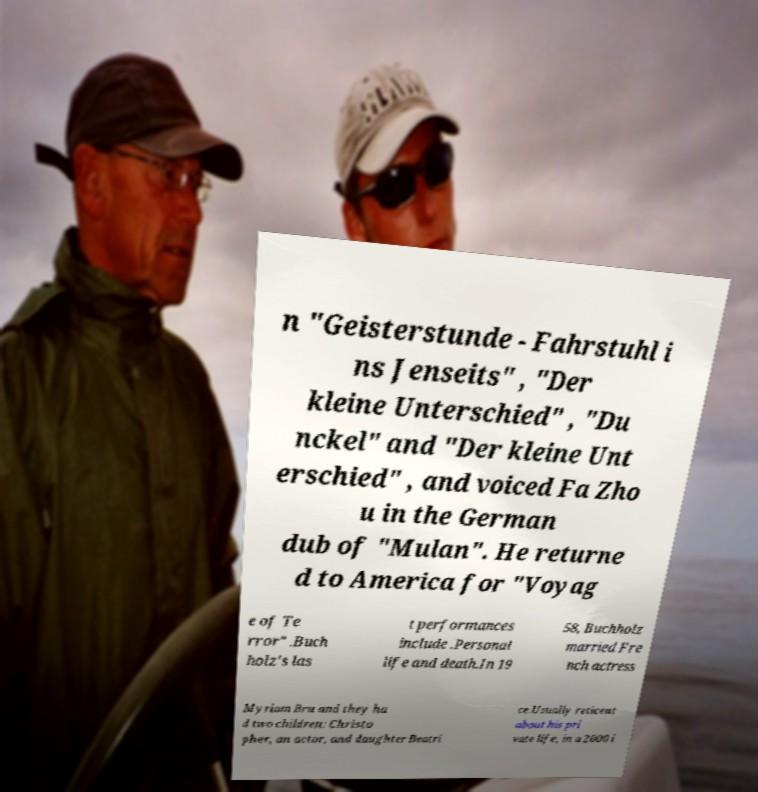Could you assist in decoding the text presented in this image and type it out clearly? n "Geisterstunde - Fahrstuhl i ns Jenseits" , "Der kleine Unterschied" , "Du nckel" and "Der kleine Unt erschied" , and voiced Fa Zho u in the German dub of "Mulan". He returne d to America for "Voyag e of Te rror" .Buch holz's las t performances include .Personal life and death.In 19 58, Buchholz married Fre nch actress Myriam Bru and they ha d two children: Christo pher, an actor, and daughter Beatri ce.Usually reticent about his pri vate life, in a 2000 i 